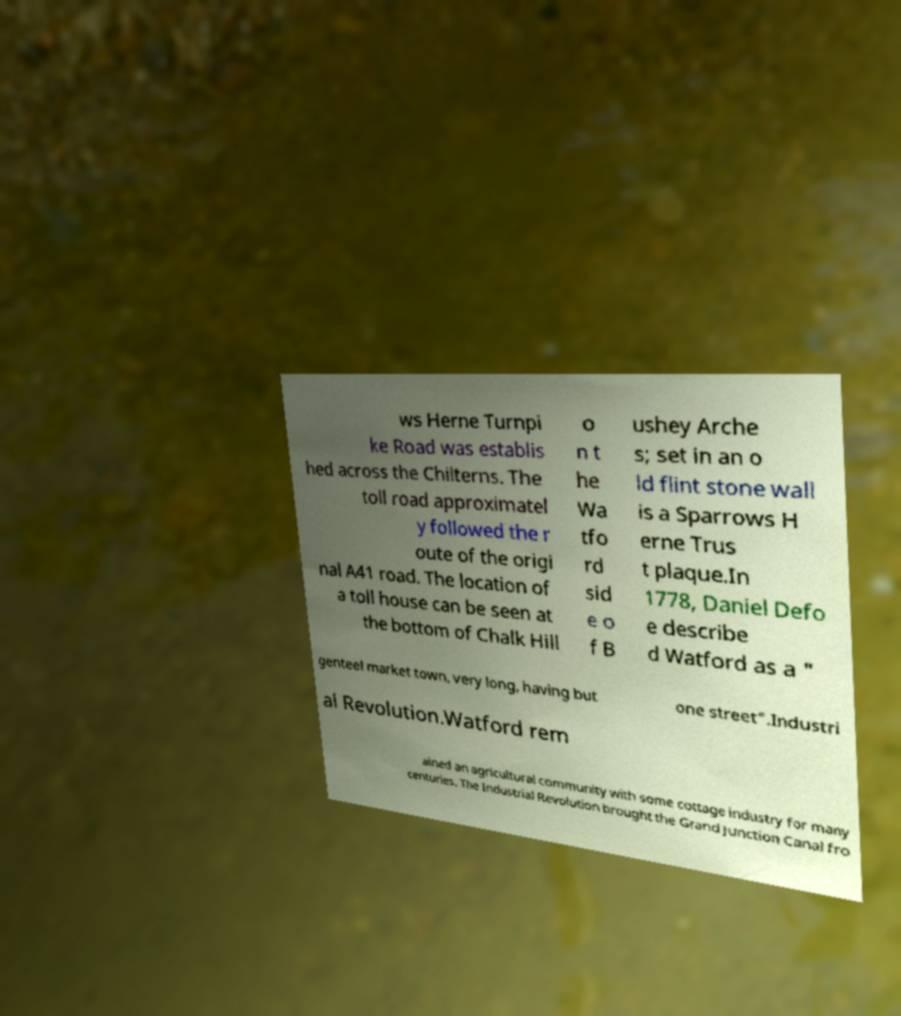I need the written content from this picture converted into text. Can you do that? ws Herne Turnpi ke Road was establis hed across the Chilterns. The toll road approximatel y followed the r oute of the origi nal A41 road. The location of a toll house can be seen at the bottom of Chalk Hill o n t he Wa tfo rd sid e o f B ushey Arche s; set in an o ld flint stone wall is a Sparrows H erne Trus t plaque.In 1778, Daniel Defo e describe d Watford as a " genteel market town, very long, having but one street".Industri al Revolution.Watford rem ained an agricultural community with some cottage industry for many centuries. The Industrial Revolution brought the Grand Junction Canal fro 